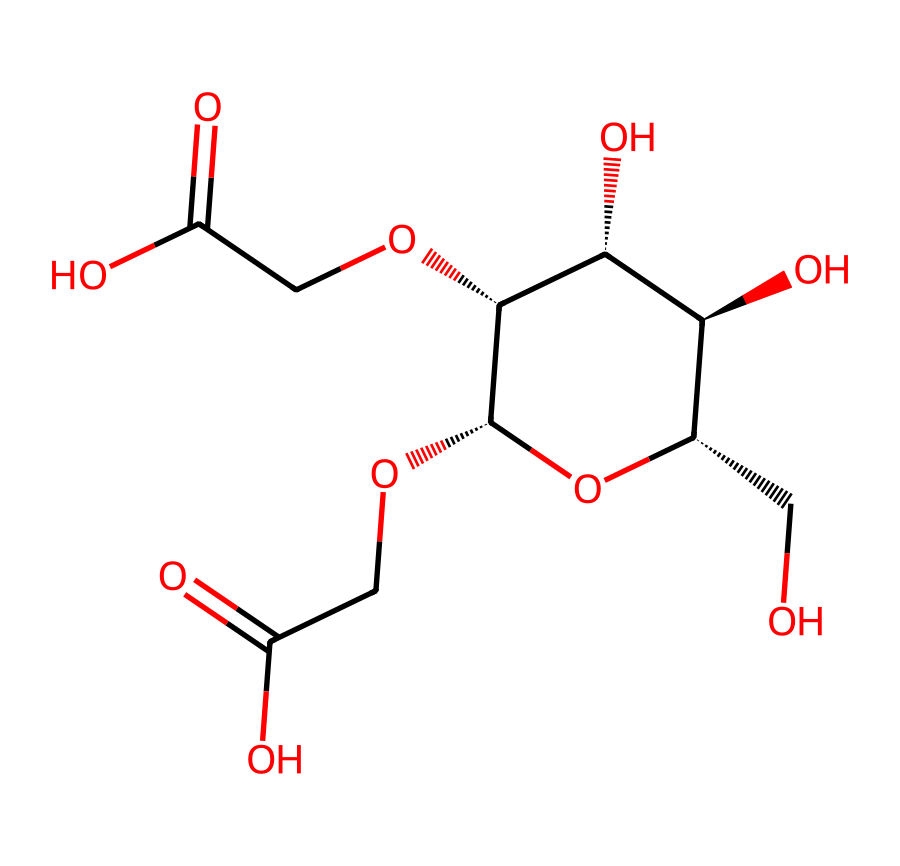What is the total number of carbon atoms in this chemical? By examining the SMILES representation, we can count the number of carbon atoms denoted by 'C'. Each 'C' in the structure represents a carbon atom. In this case, there are six distinct carbon atoms identifiable in the SMILES notation.
Answer: six How many hydroxyl (–OH) groups are present in the structure? The hydroxyl groups are indicated by the 'O' directly connected to a 'C', and in the SMILES we can see four occurrences of 'O' that are bonded to carbon atoms, indicating four hydroxyl groups present in the molecule.
Answer: four What type of functional group does the carboxymethyl part of the molecule represent? The carboxymethyl group is represented in the SMILES by 'COOC(=O)', where '(=O)' indicates a carbonyl (C=O) which, together with the hydroxyl group, forms a carboxylic acid functional group. Thus, this group represents a carboxylic acid.
Answer: carboxylic acid How does the presence of multiple hydroxyl groups affect the properties of the food additive? The presence of multiple hydroxyl groups enhances the solubility of the molecule in water, thereby improving its utility as a thickening agent, as hydroxyl groups can form hydrogen bonds with water molecules. This characteristic indicates that the compound is hydrophilic.
Answer: hydrophilic What role does this compound play in food products? Carboxymethyl cellulose acts as a thickening agent and stabilizer in food products, helping to improve texture and prevent separation of ingredients by enhancing viscosity and stability.
Answer: thickening agent and stabilizer Does this compound contain any chiral centers? In the SMILES representation, the presence of '@' indicates chiral centers, and by analyzing the molecular structure, it is clear that there are three chiral centers present, resulting from the arrangement of specific carbon atoms.
Answer: three 